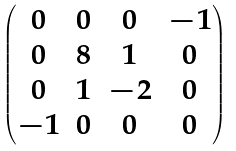Convert formula to latex. <formula><loc_0><loc_0><loc_500><loc_500>\begin{pmatrix} 0 & 0 & 0 & - 1 \\ 0 & 8 & 1 & 0 \\ 0 & 1 & - 2 & 0 \\ - 1 & 0 & 0 & 0 \end{pmatrix}</formula> 